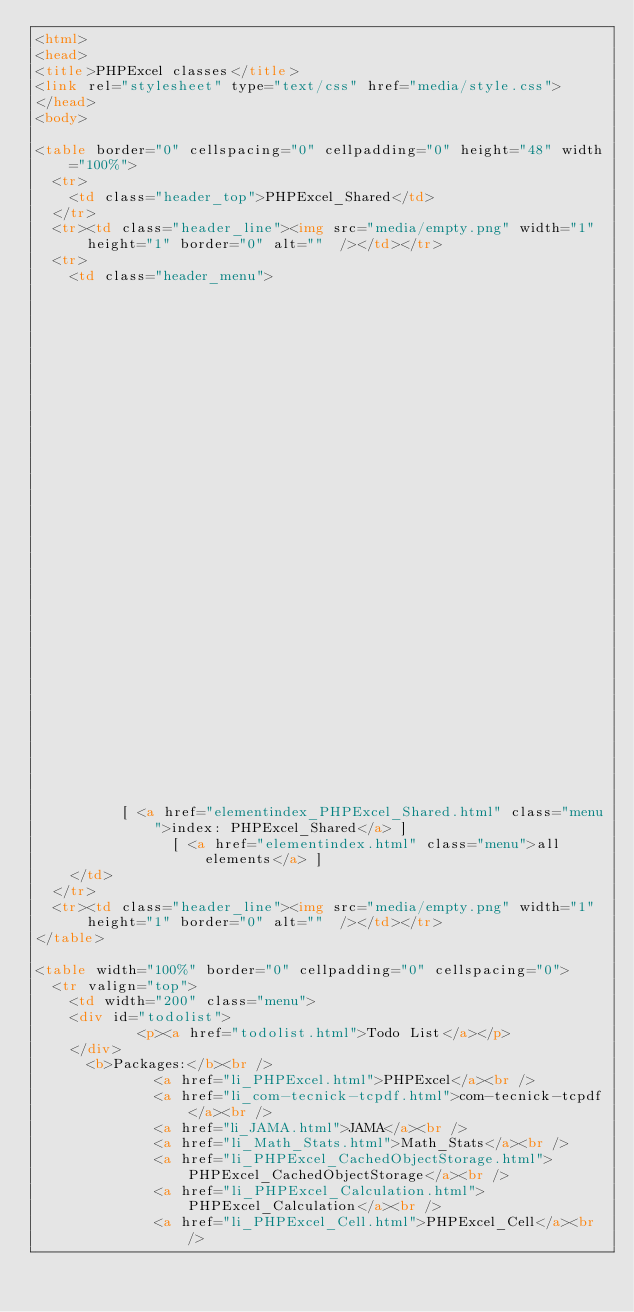Convert code to text. <code><loc_0><loc_0><loc_500><loc_500><_HTML_><html>
<head>
<title>PHPExcel classes</title>
<link rel="stylesheet" type="text/css" href="media/style.css">
</head>
<body>

<table border="0" cellspacing="0" cellpadding="0" height="48" width="100%">
  <tr>
    <td class="header_top">PHPExcel_Shared</td>
  </tr>
  <tr><td class="header_line"><img src="media/empty.png" width="1" height="1" border="0" alt=""  /></td></tr>
  <tr>
    <td class="header_menu">
        
                                                                                                                                                                                                                                                                                    
                                                                                                                                                                                                                                      		  [ <a href="classtrees_PHPExcel_Shared.html" class="menu">class tree: PHPExcel_Shared</a> ]
		  [ <a href="elementindex_PHPExcel_Shared.html" class="menu">index: PHPExcel_Shared</a> ]
		  	    [ <a href="elementindex.html" class="menu">all elements</a> ]
    </td>
  </tr>
  <tr><td class="header_line"><img src="media/empty.png" width="1" height="1" border="0" alt=""  /></td></tr>
</table>

<table width="100%" border="0" cellpadding="0" cellspacing="0">
  <tr valign="top">
    <td width="200" class="menu">
	<div id="todolist">
			<p><a href="todolist.html">Todo List</a></p>
	</div>
      <b>Packages:</b><br />
              <a href="li_PHPExcel.html">PHPExcel</a><br />
              <a href="li_com-tecnick-tcpdf.html">com-tecnick-tcpdf</a><br />
              <a href="li_JAMA.html">JAMA</a><br />
              <a href="li_Math_Stats.html">Math_Stats</a><br />
              <a href="li_PHPExcel_CachedObjectStorage.html">PHPExcel_CachedObjectStorage</a><br />
              <a href="li_PHPExcel_Calculation.html">PHPExcel_Calculation</a><br />
              <a href="li_PHPExcel_Cell.html">PHPExcel_Cell</a><br /></code> 